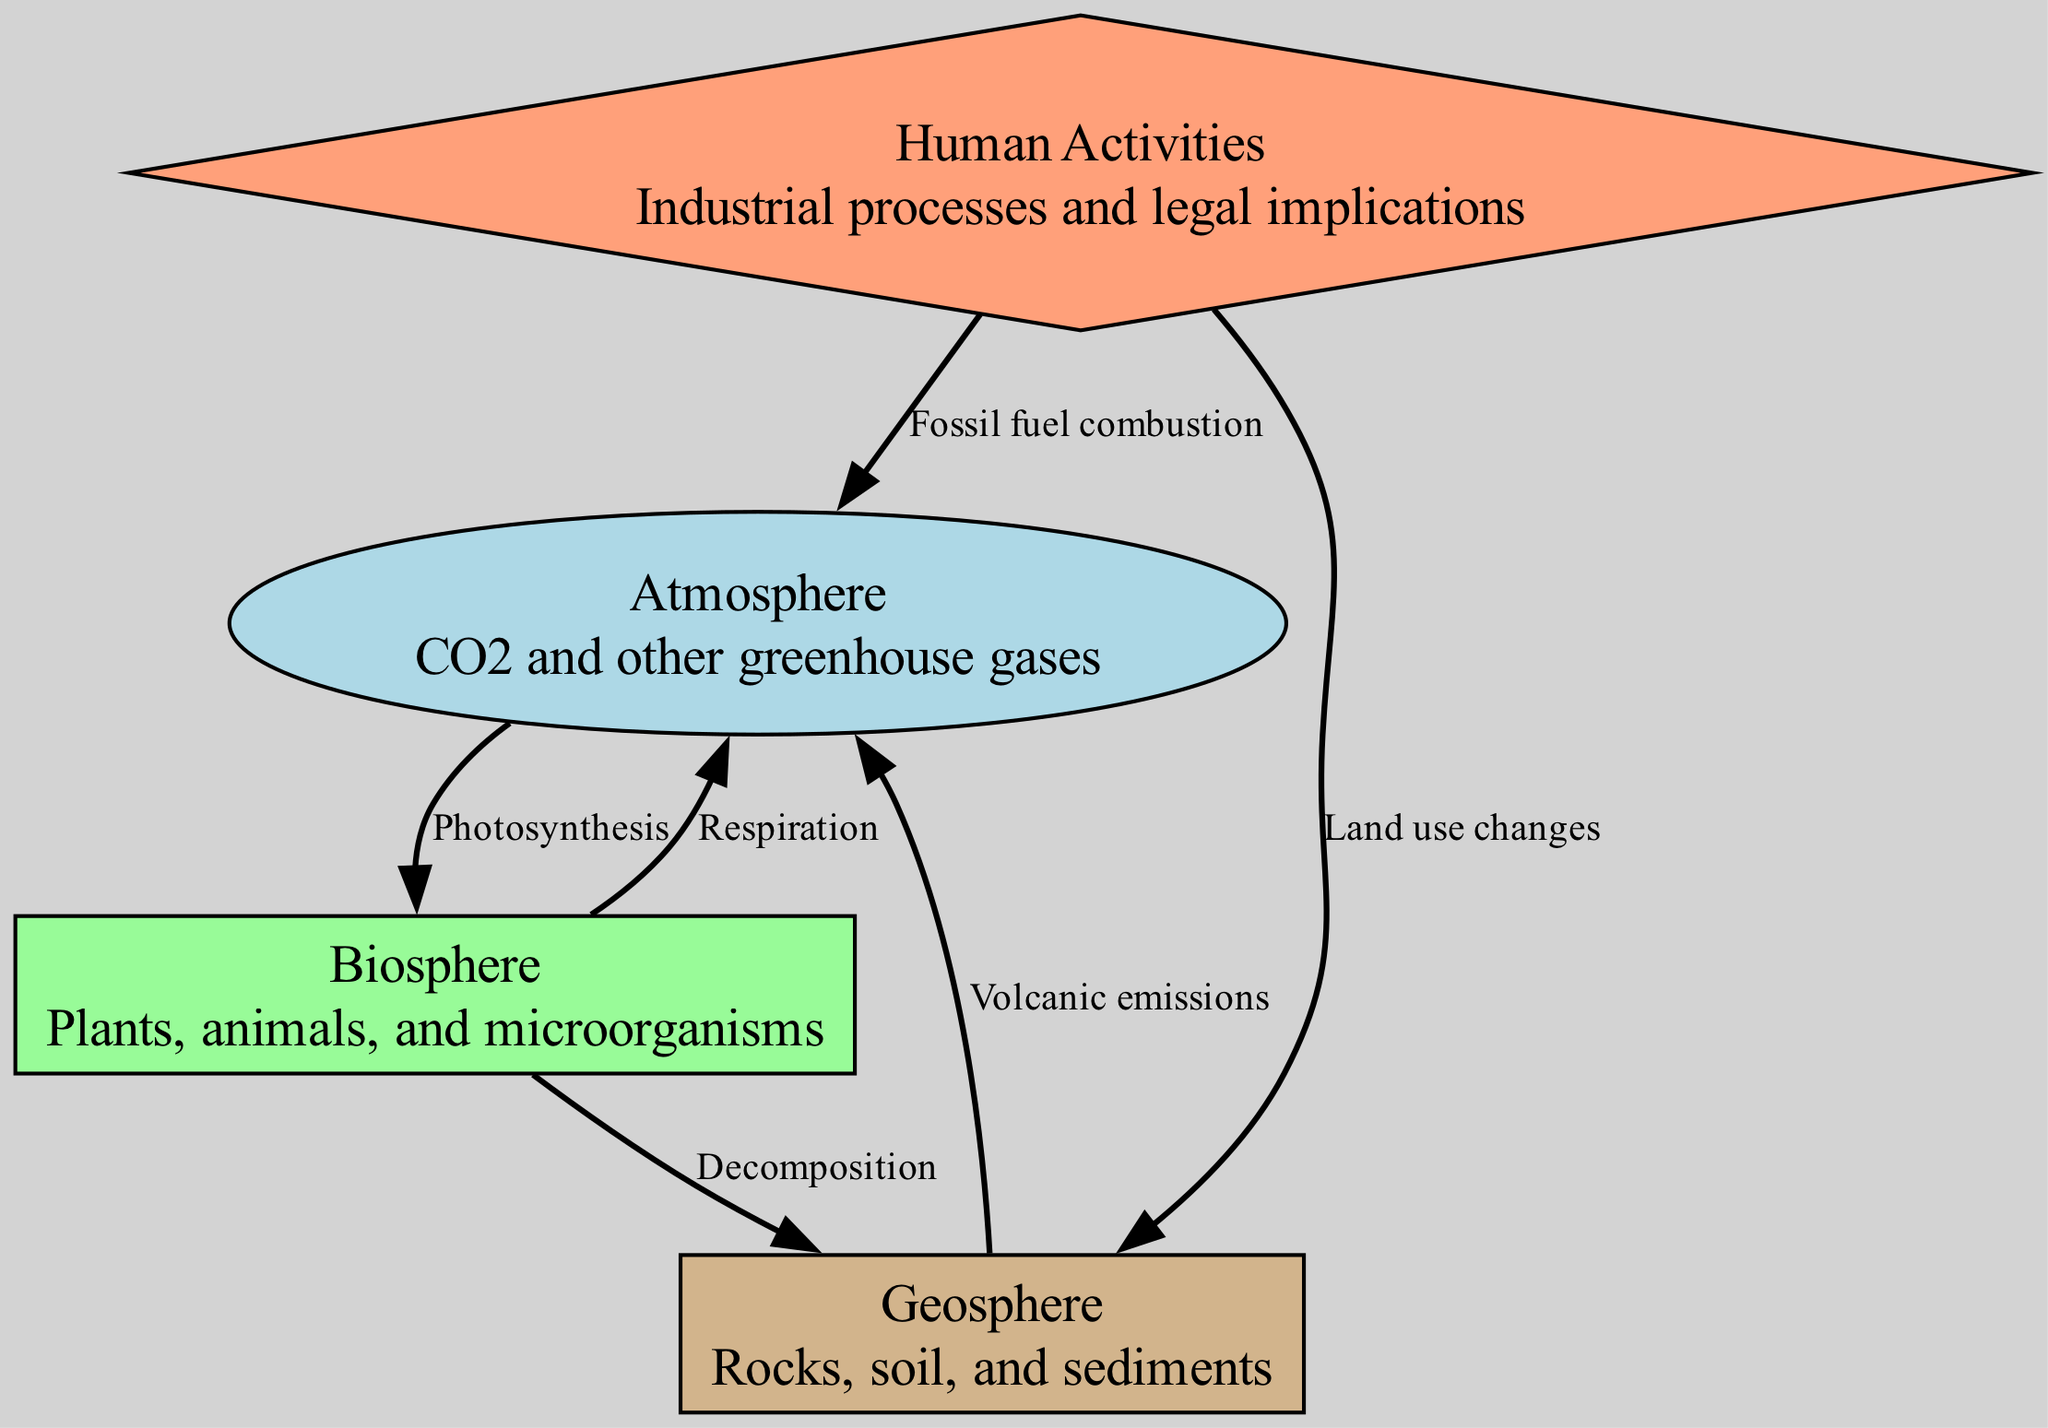What are the three main components of the carbon cycle shown in the diagram? The diagram includes three main components: Atmosphere, Biosphere, and Geosphere. Each component is represented by nodes that describe their role in the carbon cycle.
Answer: Atmosphere, Biosphere, Geosphere What process connects the Atmosphere to the Biosphere? The diagram illustrates that Photosynthesis connects the Atmosphere (where CO2 is present) to the Biosphere (where plants utilize CO2). This is depicted by the directed edge labeled "Photosynthesis" from Atmosphere to Biosphere.
Answer: Photosynthesis How many edges are present in the diagram? To find the number of edges, we count the connections depicted between the nodes: there are six directed edges shown in the diagram.
Answer: 6 Which node receives carbon from Decomposition? According to the diagram, the Biosphere is connected to the Geosphere via the edge labeled "Decomposition," indicating that carbon flows from the Biosphere to the Geosphere.
Answer: Geosphere What is the role of Human Activities in the carbon cycle? The Human Activities node sends carbon to both the Atmosphere and the Geosphere through Fossil fuel combustion and Land use changes, respectively. This shows how human actions contribute to carbon emissions.
Answer: Contributes to emissions What is the relationship between the Geosphere and the Atmosphere? The diagram indicates that the Geosphere releases carbon into the Atmosphere through Volcanic emissions, showing a connection that allows carbon to return to the atmosphere from geological processes.
Answer: Volcanic emissions Which component of the diagram represents living organisms? The Biosphere node represents living organisms such as plants, animals, and microorganisms, which are actively involved in the carbon cycle as both sources and sinks of carbon.
Answer: Biosphere What effect do Human Activities have on the Atmosphere? The diagram shows that Human Activities, particularly through Fossil fuel combustion, increase carbon levels in the Atmosphere. This illustrates the anthropogenic impact on carbon levels in the air.
Answer: Increase carbon levels 